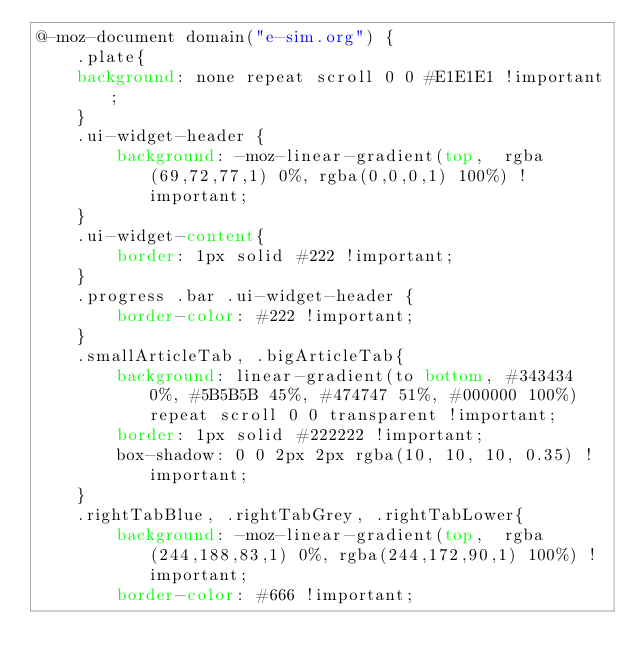<code> <loc_0><loc_0><loc_500><loc_500><_CSS_>@-moz-document domain("e-sim.org") {
    .plate{
    background: none repeat scroll 0 0 #E1E1E1 !important;
    }
    .ui-widget-header {
        background: -moz-linear-gradient(top,  rgba(69,72,77,1) 0%, rgba(0,0,0,1) 100%) !important;
    }
    .ui-widget-content{
        border: 1px solid #222 !important;
    }
    .progress .bar .ui-widget-header {
        border-color: #222 !important;
    }
    .smallArticleTab, .bigArticleTab{
        background: linear-gradient(to bottom, #343434 0%, #5B5B5B 45%, #474747 51%, #000000 100%) repeat scroll 0 0 transparent !important;
        border: 1px solid #222222 !important;
        box-shadow: 0 0 2px 2px rgba(10, 10, 10, 0.35) !important;
    }
    .rightTabBlue, .rightTabGrey, .rightTabLower{
        background: -moz-linear-gradient(top,  rgba(244,188,83,1) 0%, rgba(244,172,90,1) 100%) !important;
        border-color: #666 !important;</code> 